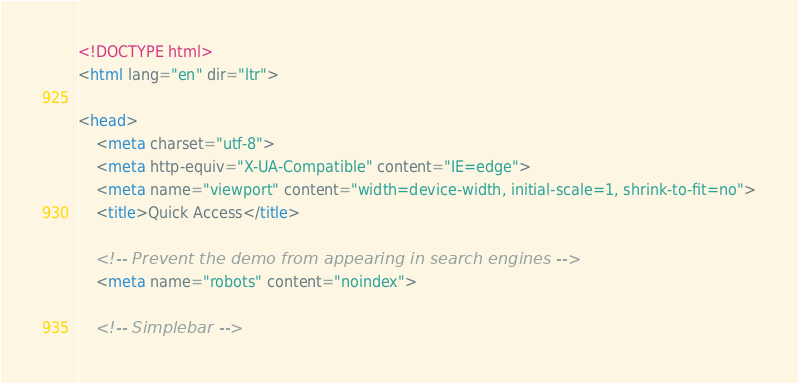Convert code to text. <code><loc_0><loc_0><loc_500><loc_500><_HTML_><!DOCTYPE html>
<html lang="en" dir="ltr">

<head>
    <meta charset="utf-8">
    <meta http-equiv="X-UA-Compatible" content="IE=edge">
    <meta name="viewport" content="width=device-width, initial-scale=1, shrink-to-fit=no">
    <title>Quick Access</title>

    <!-- Prevent the demo from appearing in search engines -->
    <meta name="robots" content="noindex">

    <!-- Simplebar --></code> 